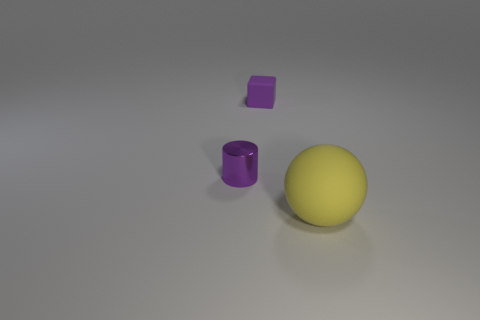What time of day or lighting environment would you say the image represents? The image appears to be set in an indoor environment with neutral lighting. The shadows of the objects are soft and diffuse, indicating that the light source might be artificial, like overhead fluorescent lighting, rather than natural sunlight. 